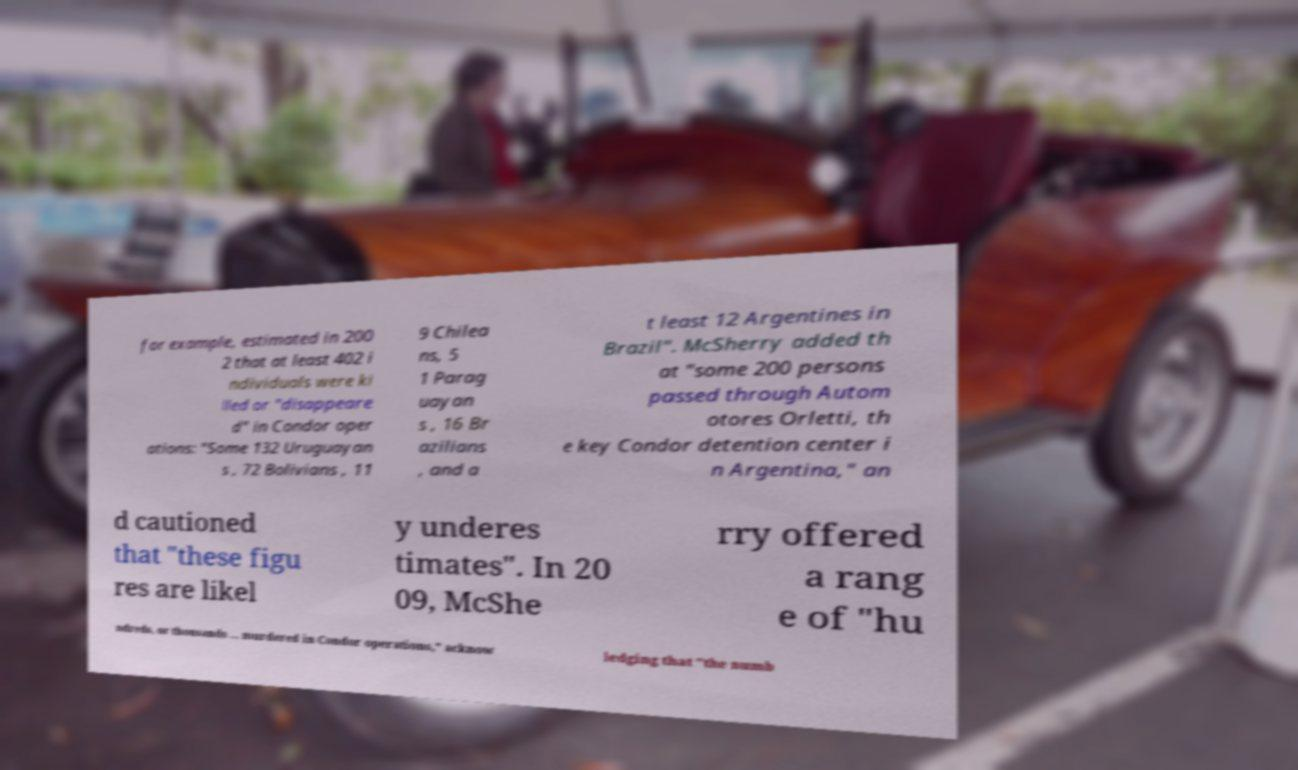Please read and relay the text visible in this image. What does it say? for example, estimated in 200 2 that at least 402 i ndividuals were ki lled or "disappeare d" in Condor oper ations: "Some 132 Uruguayan s , 72 Bolivians , 11 9 Chilea ns, 5 1 Parag uayan s , 16 Br azilians , and a t least 12 Argentines in Brazil". McSherry added th at "some 200 persons passed through Autom otores Orletti, th e key Condor detention center i n Argentina," an d cautioned that "these figu res are likel y underes timates". In 20 09, McShe rry offered a rang e of "hu ndreds, or thousands ... murdered in Condor operations," acknow ledging that "the numb 